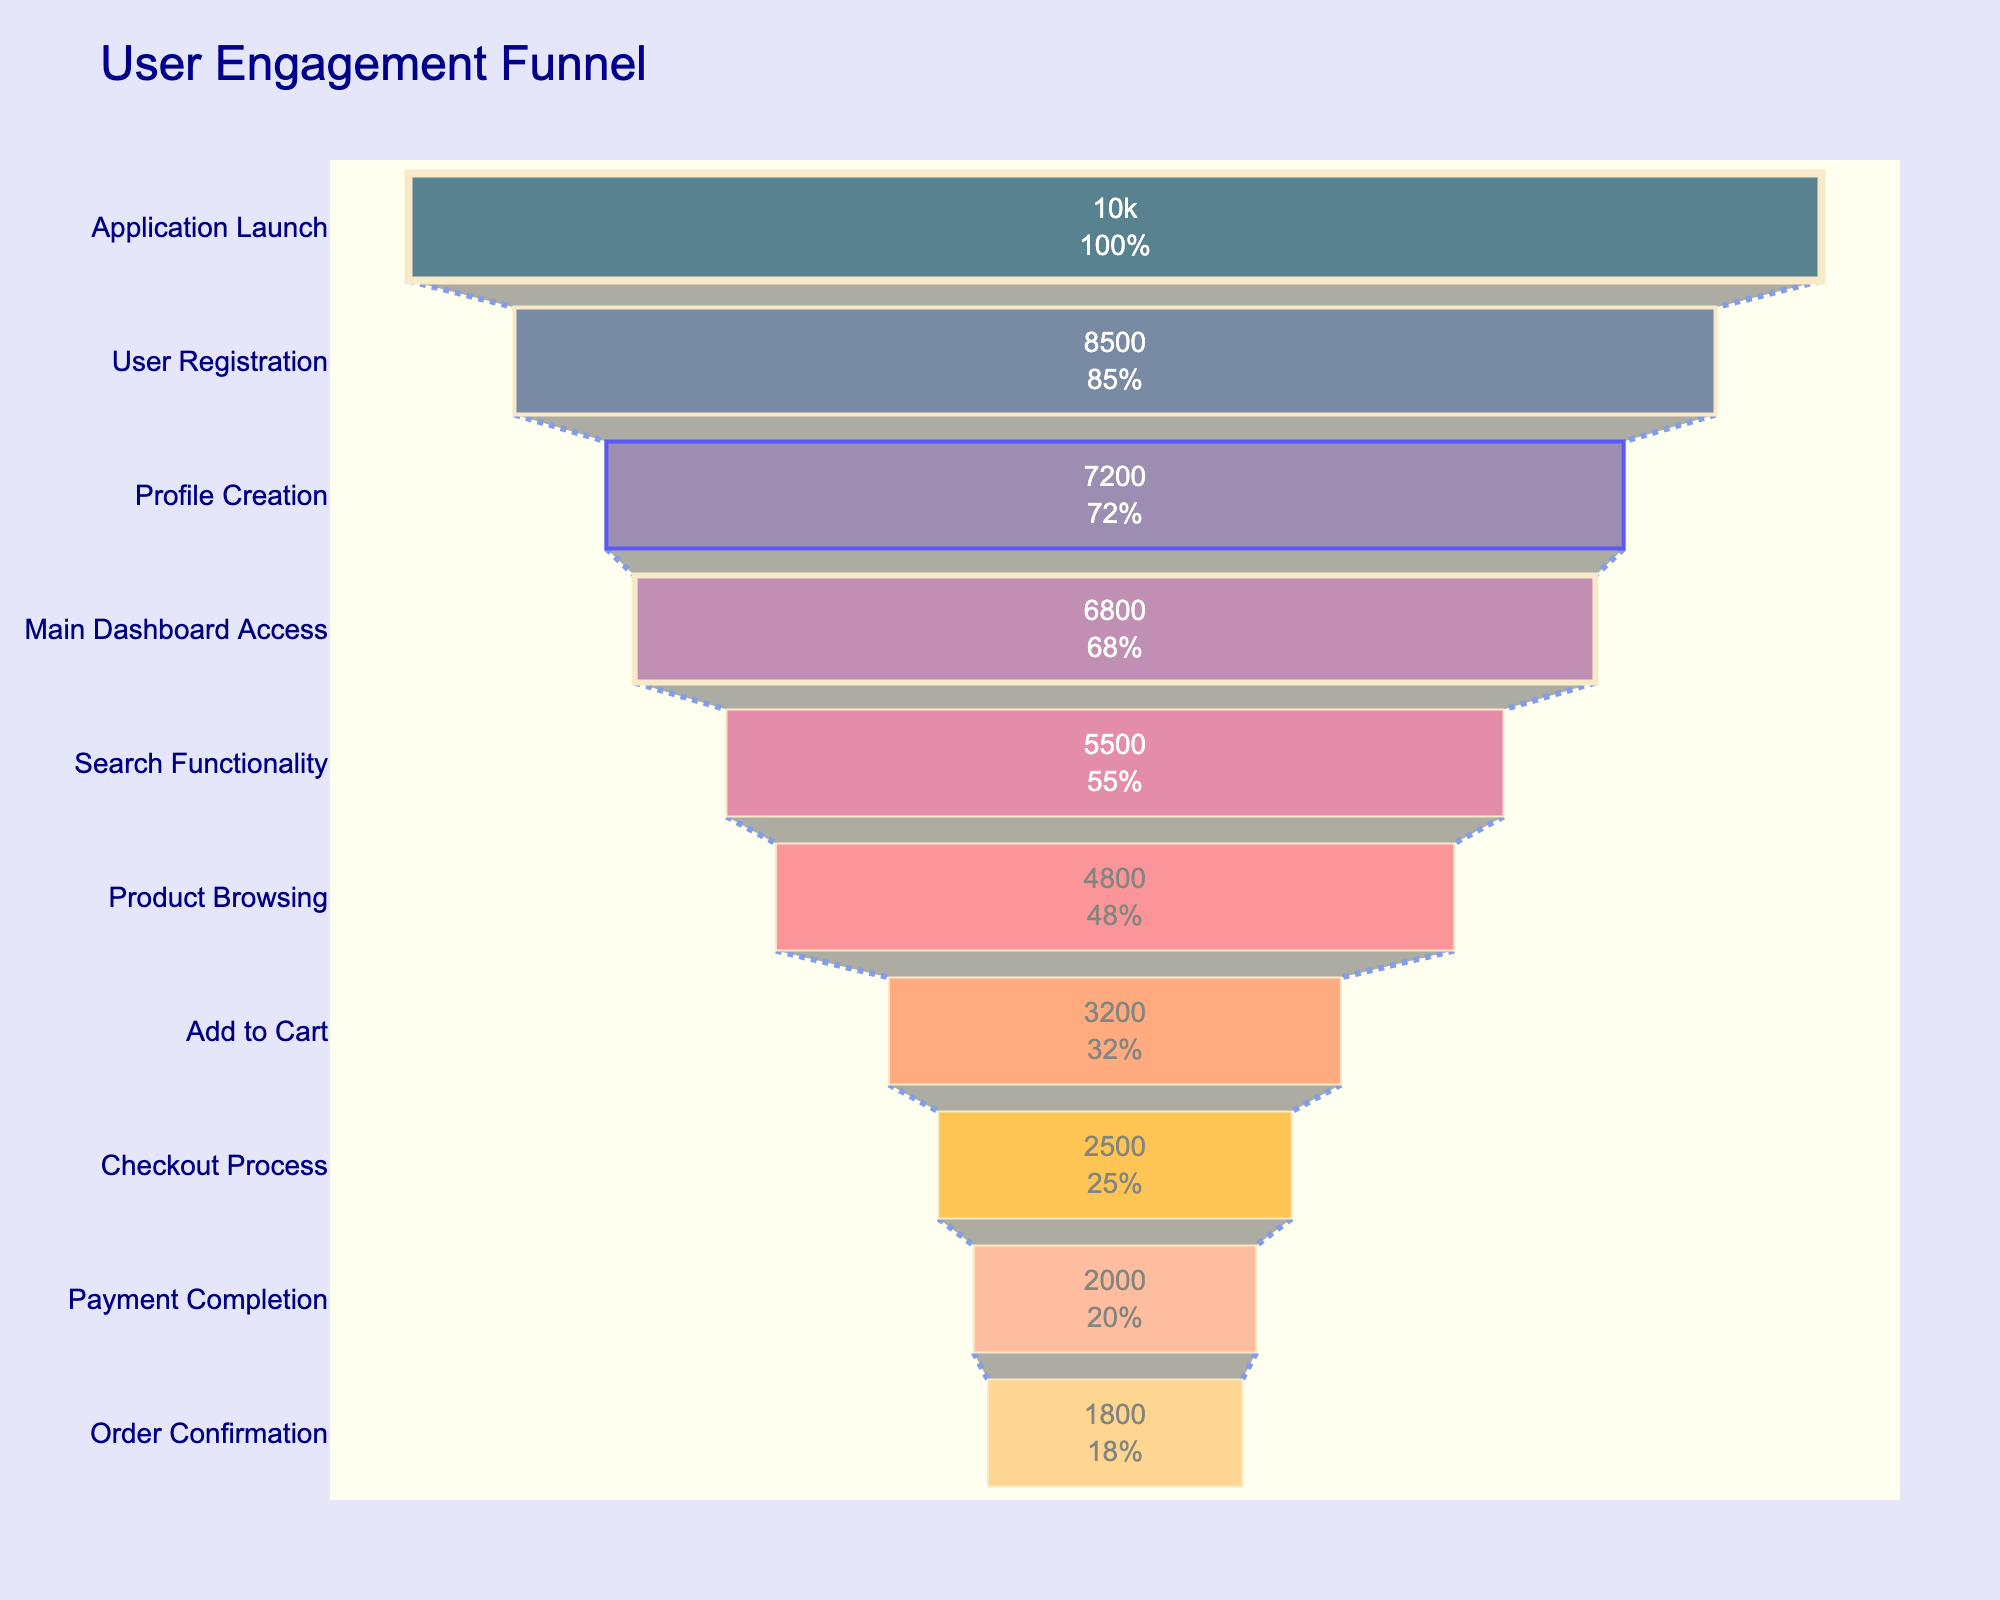What is the title of the funnel chart? The title is visible at the top of the chart in larger font size, typically indicating the overarching theme or subject of the data presented.
Answer: User Engagement Funnel How many features are listed in the funnel chart? To determine the number of features, count the distinct labels on the vertical axis (y-axis) representing each step in the funnel.
Answer: 10 Which feature has the highest number of users? To find the feature with the highest number of users, look for the segment of the funnel with the widest width at the top, indicating the maximum value.
Answer: Application Launch How many users are lost between 'User Registration' and 'Profile Creation'? Subtract the number of users at 'Profile Creation' from the number of users at 'User Registration' (8500 - 7200).
Answer: 1300 What is the percentage of users who complete the 'Payment Completion' step out of the initial users in 'Application Launch'? Calculate the percentage by dividing the number of users at 'Payment Completion' (2000) by the initial number of users in 'Application Launch' (10000), then multiply by 100% (2000/10000 * 100%). Follow these steps: 2000 ÷ 10000 = 0.2 → 0.2 × 100% = 20%.
Answer: 20% Which features have fewer than 3000 users? Identify segments in the funnel chart where the user count is less than 3000; these are 'Add to Cart', 'Checkout Process', 'Payment Completion', and 'Order Confirmation'.
Answer: Add to Cart, Checkout Process, Payment Completion, Order Confirmation By how many users does 'Search Functionality' exceed 'Product Browsing'? Subtract the number of users in 'Product Browsing' from 'Search Functionality' (5500 - 4800).
Answer: 700 What is the sequence of the features with user counts reducing by at least 1000 from one step to the next? Examine the drop in user counts between each feature and list the sequences where the difference is 1000 or more: 'User Registration' to 'Profile Creation' (8500 to 7200), 'Main Dashboard Access' to 'Search Functionality' (6800 to 5500), and 'Add to Cart' to 'Checkout Process' (3200 to 2500).
Answer: User Registration > Profile Creation, Main Dashboard Access > Search Functionality, Add to Cart > Checkout Process Which step results in the smallest drop in user count in the funnel? Determine the smallest numerical difference between consecutive steps: the difference is smallest between 'Profile Creation' and 'Main Dashboard Access' (7200 to 6800).
Answer: Profile Creation to Main Dashboard Access What is the sum of the users in 'Checkout Process' and 'Payment Completion'? Add the user counts for 'Checkout Process' and 'Payment Completion' (2500 + 2000).
Answer: 4500 